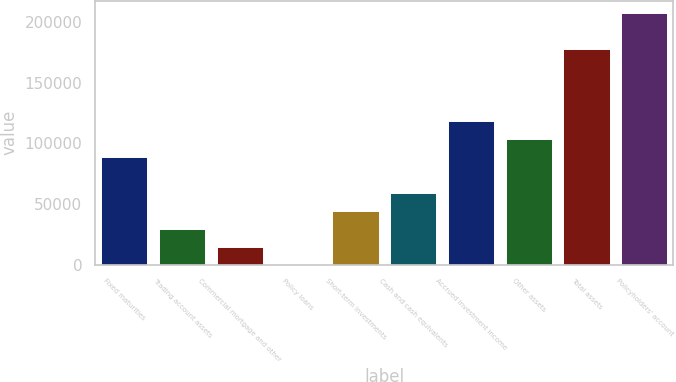Convert chart to OTSL. <chart><loc_0><loc_0><loc_500><loc_500><bar_chart><fcel>Fixed maturities<fcel>Trading account assets<fcel>Commercial mortgage and other<fcel>Policy loans<fcel>Short-term investments<fcel>Cash and cash equivalents<fcel>Accrued investment income<fcel>Other assets<fcel>Total assets<fcel>Policyholders' account<nl><fcel>88756.3<fcel>29588.6<fcel>14796.7<fcel>4.78<fcel>44380.5<fcel>59172.5<fcel>118340<fcel>103548<fcel>177508<fcel>207092<nl></chart> 